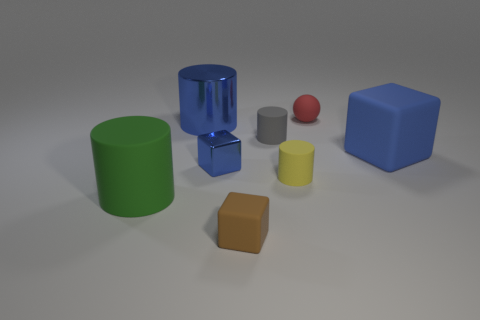Subtract all tiny gray cylinders. How many cylinders are left? 3 Subtract all brown spheres. How many blue cubes are left? 2 Subtract all green cylinders. How many cylinders are left? 3 Add 1 red spheres. How many objects exist? 9 Subtract all blocks. How many objects are left? 5 Subtract all red cylinders. Subtract all green blocks. How many cylinders are left? 4 Add 1 small yellow metallic things. How many small yellow metallic things exist? 1 Subtract 0 gray spheres. How many objects are left? 8 Subtract all gray objects. Subtract all large blocks. How many objects are left? 6 Add 1 red objects. How many red objects are left? 2 